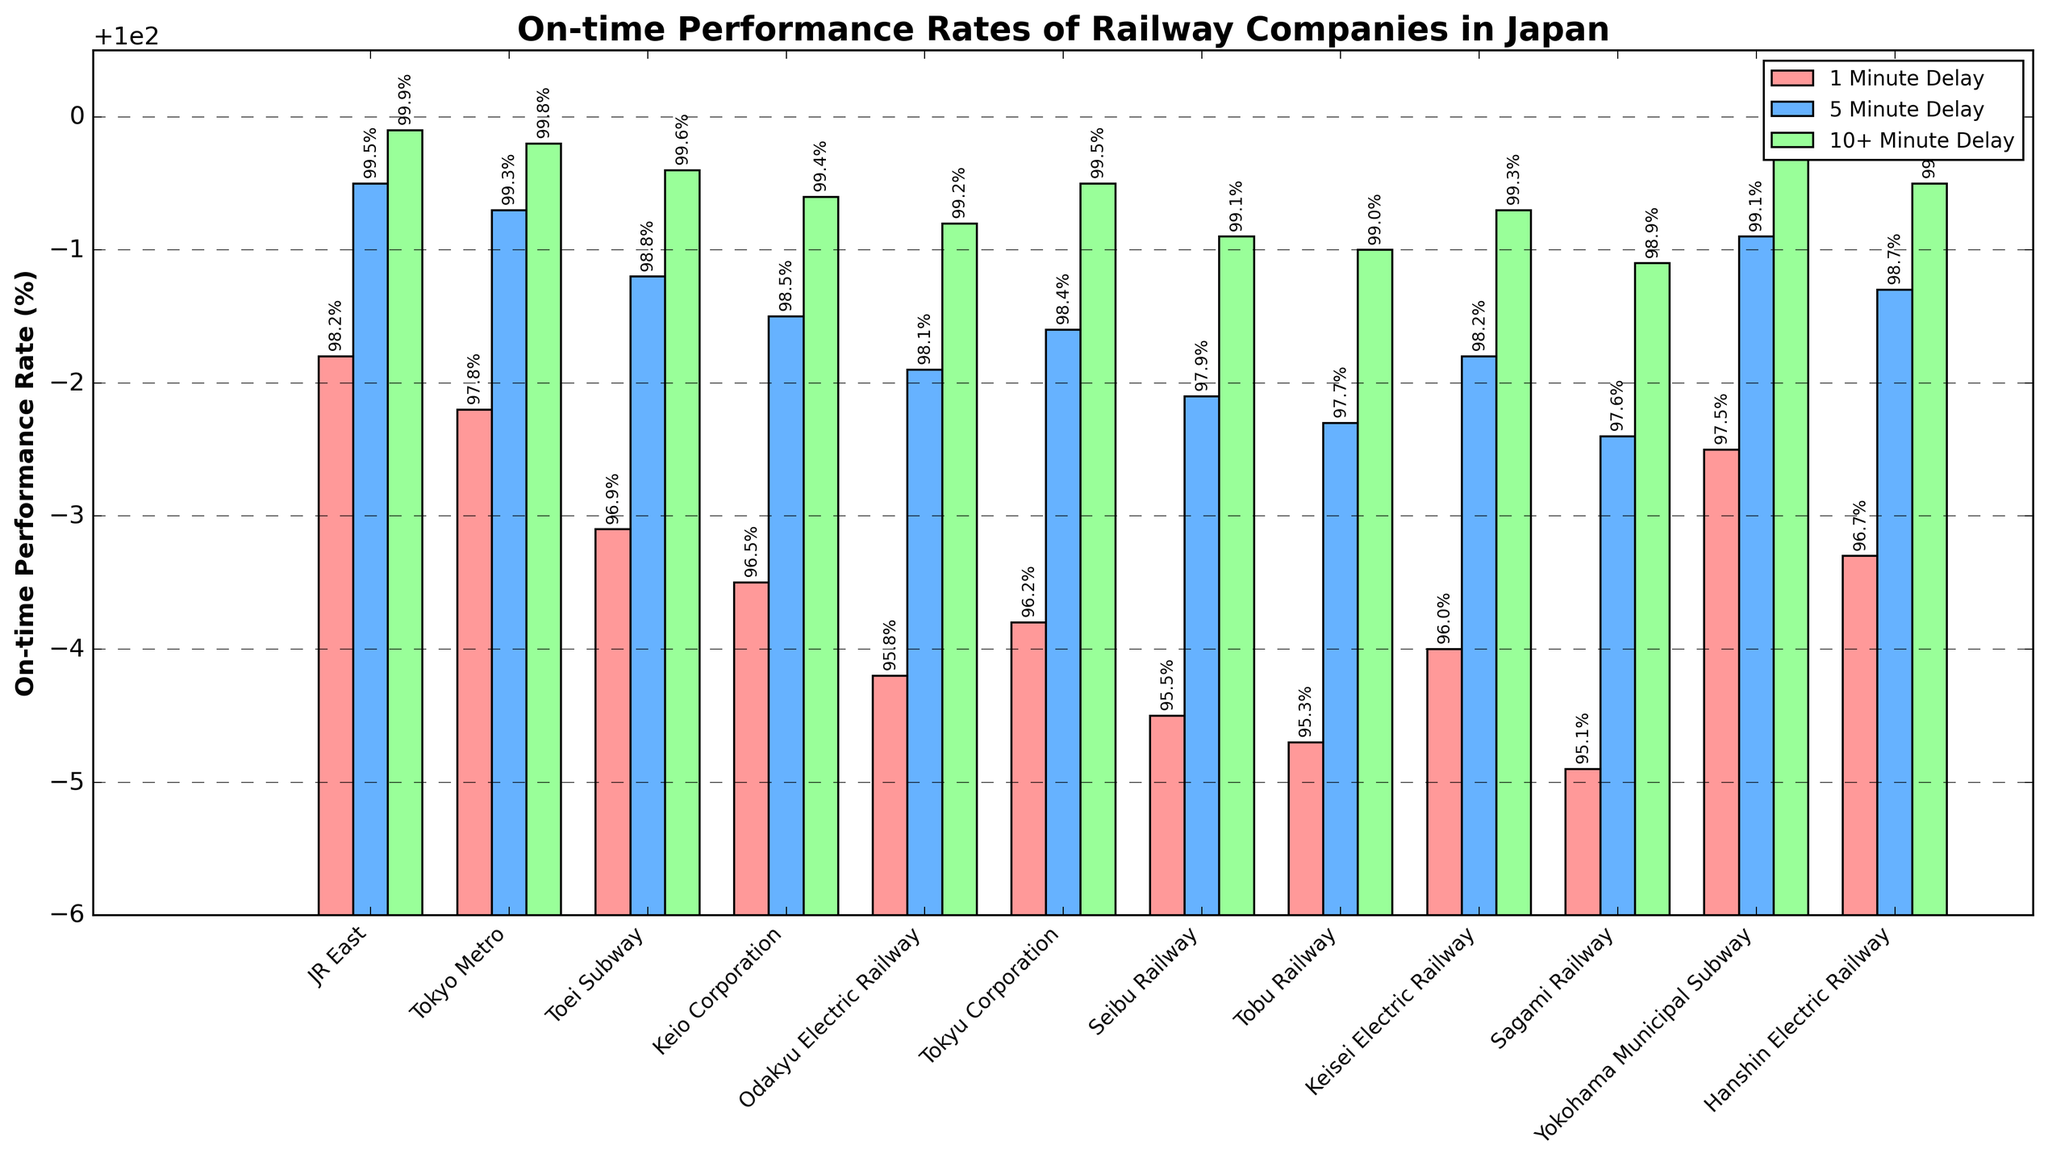Which railway company has the highest on-time performance rate for a 1 minute delay? To find the highest on-time performance rate for a 1 minute delay, look at the red bars representing each company. The tallest bar for 1 minute delay is JR East.
Answer: JR East How much higher is JR East's on-time performance rate for a 1 minute delay compared to Seibu Railway? Find the height of the red bars for JR East and Seibu Railway. JR East has 98.2% while Seibu Railway has 95.5%. The difference is 98.2% - 95.5% = 2.7%.
Answer: 2.7% Which company has the lowest on-time performance rate for a 5 minute delay and what is the value? Look at the blue bars representing each company's 5 minute delay rate. The shortest blue bar is for Sagami Railway, which has a rate of 97.6%.
Answer: Sagami Railway, 97.6% Between Tokyo Metro and Toei Subway, which has a better on-time performance rate for delays of 10+ minutes? Check the heights of the green bars for both Tokyo Metro and Toei Subway. Tokyo Metro's green bar is slightly higher at 99.8% compared to Toei Subway's 99.6%.
Answer: Tokyo Metro What is the average on-time performance rate across all companies for a 1 minute delay? Sum the 1 minute delay rates for all companies (98.2 + 97.8 + 96.9 + 96.5 + 95.8 + 96.2 + 95.5 + 95.3 + 96.0 + 95.1 + 97.5 + 96.7) and divide by the total number of companies (12). The total is 1157.5, so the average is 1157.5 / 12 = 96.46%.
Answer: 96.46% What company is the closest to a perfect on-time performance rate (100%) for delays of 10+ minutes? Check the heights of the green bars and find the one closest to 100%. JR East has a 10+ minute delay rate of 99.9%, which is the closest to 100%.
Answer: JR East How much higher is the on-time performance rate for delays of 10+ minutes compared to 1 minute delays for Tokyu Corporation? For Tokyu Corporation, the 1 minute delay rate is 96.2% and the 10+ minute delay rate is 99.5%. The difference is 99.5% - 96.2% = 3.3%.
Answer: 3.3% Which companies have an on-time performance rate above 99% for 5 minute delays? Look at the blue bars and identify the companies with heights above 99%. JR East (99.5%), Tokyo Metro (99.3%), Yokohama Municipal Subway (99.1%) meet this criterion.
Answer: JR East, Tokyo Metro, Yokohama Municipal Subway Compare the on-time performance rate for 1 minute delays between Keio Corporation and Hanshin Electric Railway. Which one is better? Look at the red bars for Keio Corporation and Hanshin Electric Railway. Hanshin Electric Railway's red bar is higher at 96.7%, while Keio Corporation is 96.5%.
Answer: Hanshin Electric Railway What is the total on-time performance rate for delays of 5 minutes across all companies? Sum the 5 minute delay rates for all companies (99.5 + 99.3 + 98.8 + 98.5 + 98.1 + 98.4 + 97.9 + 97.7 + 98.2 + 97.6 + 99.1 + 98.7). The total is 1181.8%.
Answer: 1181.8% 